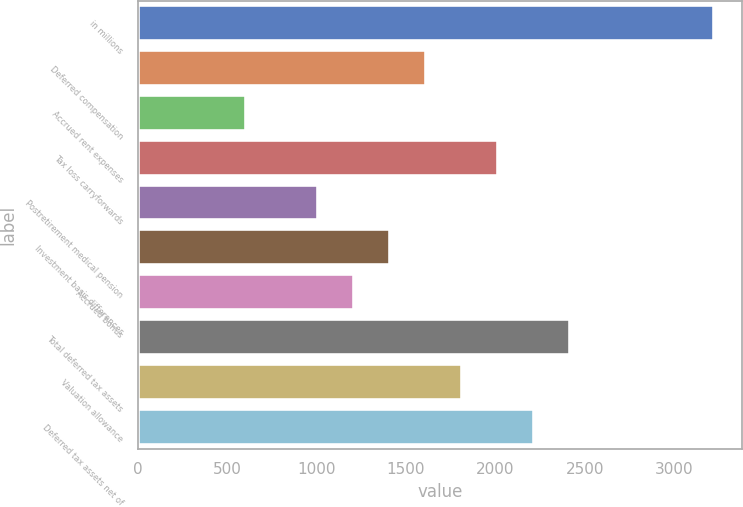Convert chart to OTSL. <chart><loc_0><loc_0><loc_500><loc_500><bar_chart><fcel>in millions<fcel>Deferred compensation<fcel>Accrued rent expenses<fcel>Tax loss carryforwards<fcel>Postretirement medical pension<fcel>Investment basis differences<fcel>Accrued bonus<fcel>Total deferred tax assets<fcel>Valuation allowance<fcel>Deferred tax assets net of<nl><fcel>3221.44<fcel>1611.52<fcel>605.32<fcel>2014<fcel>1007.8<fcel>1410.28<fcel>1209.04<fcel>2416.48<fcel>1812.76<fcel>2215.24<nl></chart> 